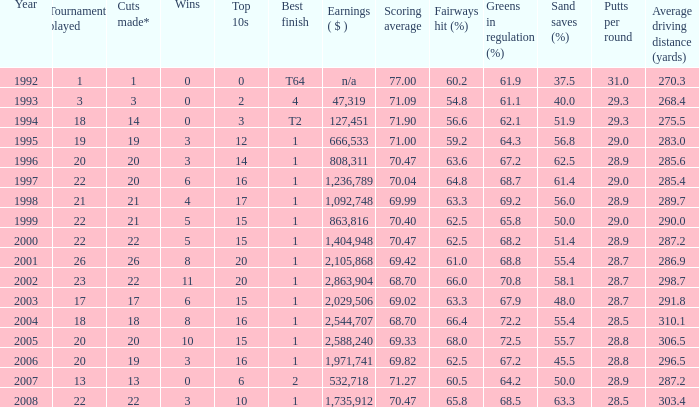Tell me the scoring average for year less than 1998 and wins more than 3 70.04. 